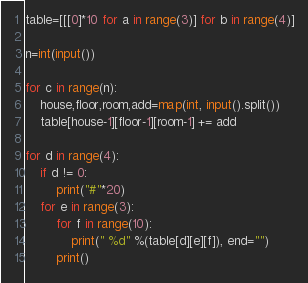Convert code to text. <code><loc_0><loc_0><loc_500><loc_500><_Python_>table=[[[0]*10 for a in range(3)] for b in range(4)]

n=int(input())

for c in range(n):
    house,floor,room,add=map(int, input().split())
    table[house-1][floor-1][room-1] += add

for d in range(4):
    if d != 0:
        print("#"*20)
    for e in range(3):
        for f in range(10):
            print(" %d" %(table[d][e][f]), end="")
        print()

</code> 